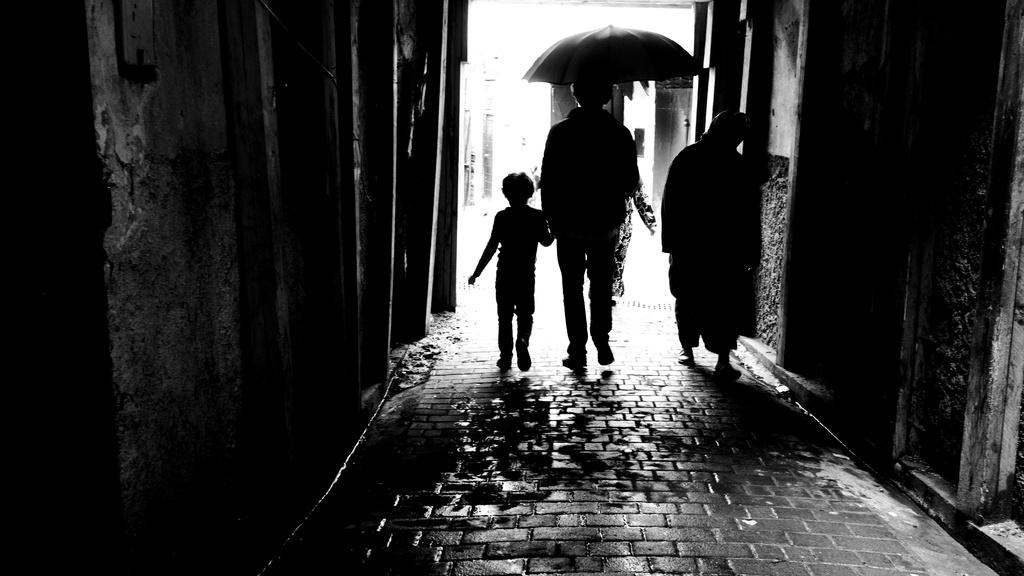What is the color scheme of the image? The image is black and white. How many people are in the image? There are three persons standing in the image. What is one person holding in the image? One person is holding an umbrella. What type of structure can be seen in the image? There are walls visible in the image. Is there a water fountain visible in the image? No, there is no water fountain present in the image. What type of pest can be seen crawling on the walls in the image? There are no pests visible in the image; only the walls and the three persons are present. 